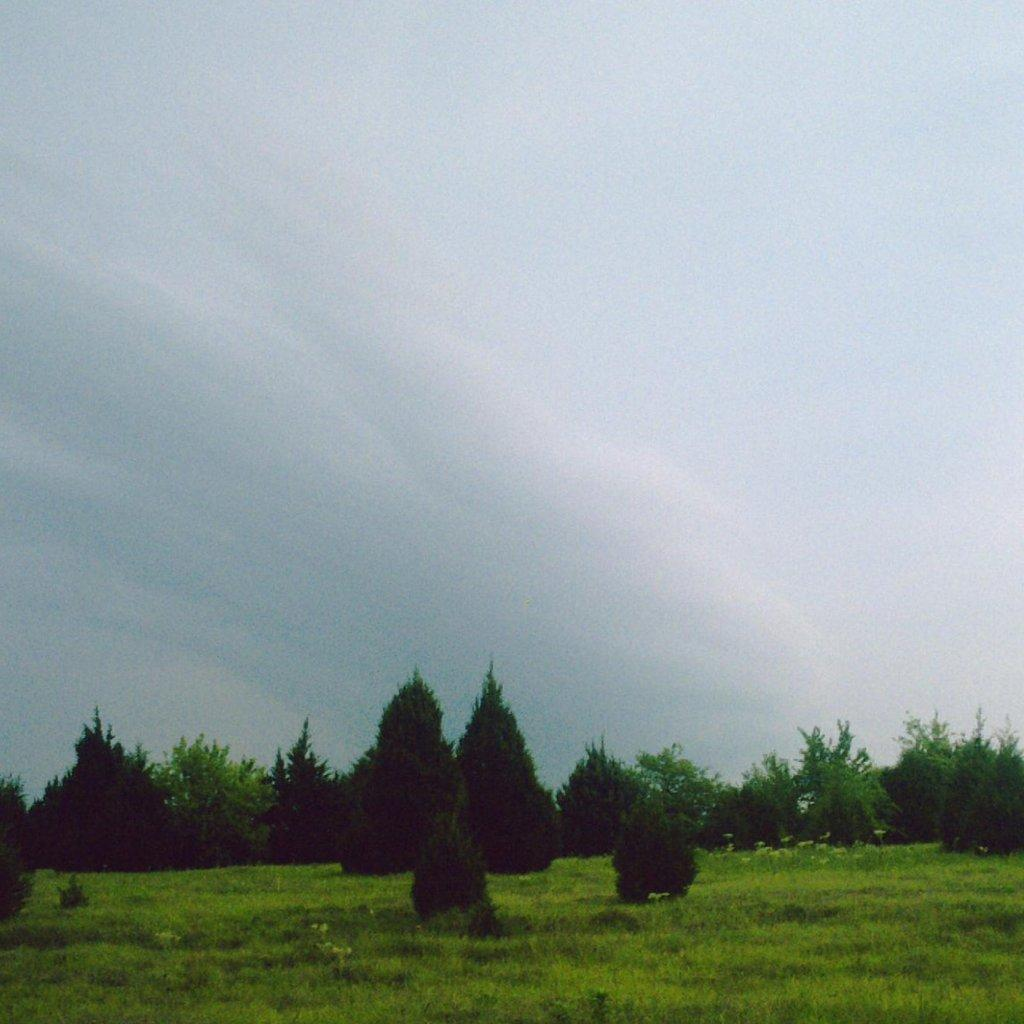What type of vegetation can be seen in the foreground of the image? There is grass and trees in the foreground of the image. What is visible at the top of the image? The sky is visible at the top of the image. What can be seen in the sky? Clouds are present in the sky. How many cents are scattered on the grass in the image? There are no cents present in the image; it only features grass, trees, and clouds in the sky. What type of rock can be seen in the image? There is no rock present in the image; it only features grass, trees, and clouds in the sky. 